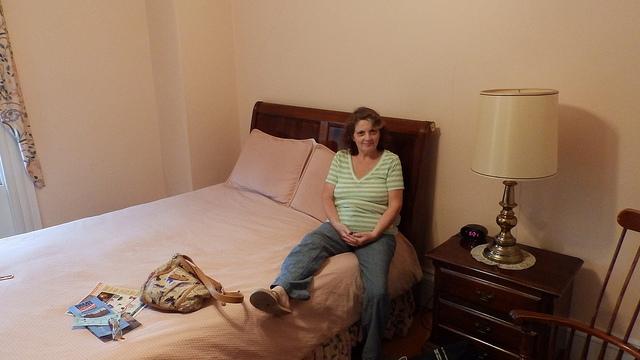Are there drawings on the wall?
Concise answer only. No. What is the girl doing?
Be succinct. Sitting. How many cats are on the bed?
Keep it brief. 0. What is the object lying on the bed?
Write a very short answer. Purse. What are the feet propped up on?
Keep it brief. Bed. Does she have a purse?
Give a very brief answer. Yes. How many babies are there?
Keep it brief. 0. Where are the red net stockings?
Give a very brief answer. No. How many light sources are in the room?
Concise answer only. 1. What color is the woman's top?
Concise answer only. Green. Does her shirt have sleeves?
Quick response, please. No. What color are the woman's shoes?
Be succinct. Brown. Is the person on the bed reading?
Write a very short answer. No. What pattern is on the blanket?
Short answer required. Solid. Is one foot on the floor?
Be succinct. Yes. Is the light on?
Answer briefly. No. Is there a cat in this photo?
Write a very short answer. No. Is the book open or closed?
Answer briefly. Closed. Is the bed messy?
Answer briefly. No. 